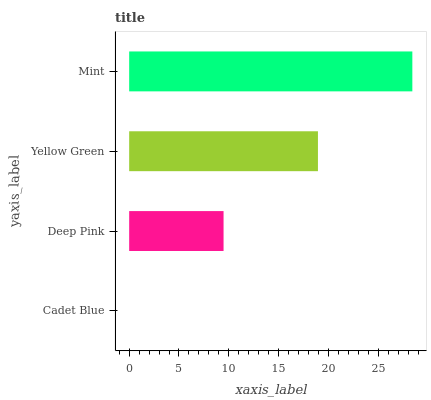Is Cadet Blue the minimum?
Answer yes or no. Yes. Is Mint the maximum?
Answer yes or no. Yes. Is Deep Pink the minimum?
Answer yes or no. No. Is Deep Pink the maximum?
Answer yes or no. No. Is Deep Pink greater than Cadet Blue?
Answer yes or no. Yes. Is Cadet Blue less than Deep Pink?
Answer yes or no. Yes. Is Cadet Blue greater than Deep Pink?
Answer yes or no. No. Is Deep Pink less than Cadet Blue?
Answer yes or no. No. Is Yellow Green the high median?
Answer yes or no. Yes. Is Deep Pink the low median?
Answer yes or no. Yes. Is Deep Pink the high median?
Answer yes or no. No. Is Cadet Blue the low median?
Answer yes or no. No. 